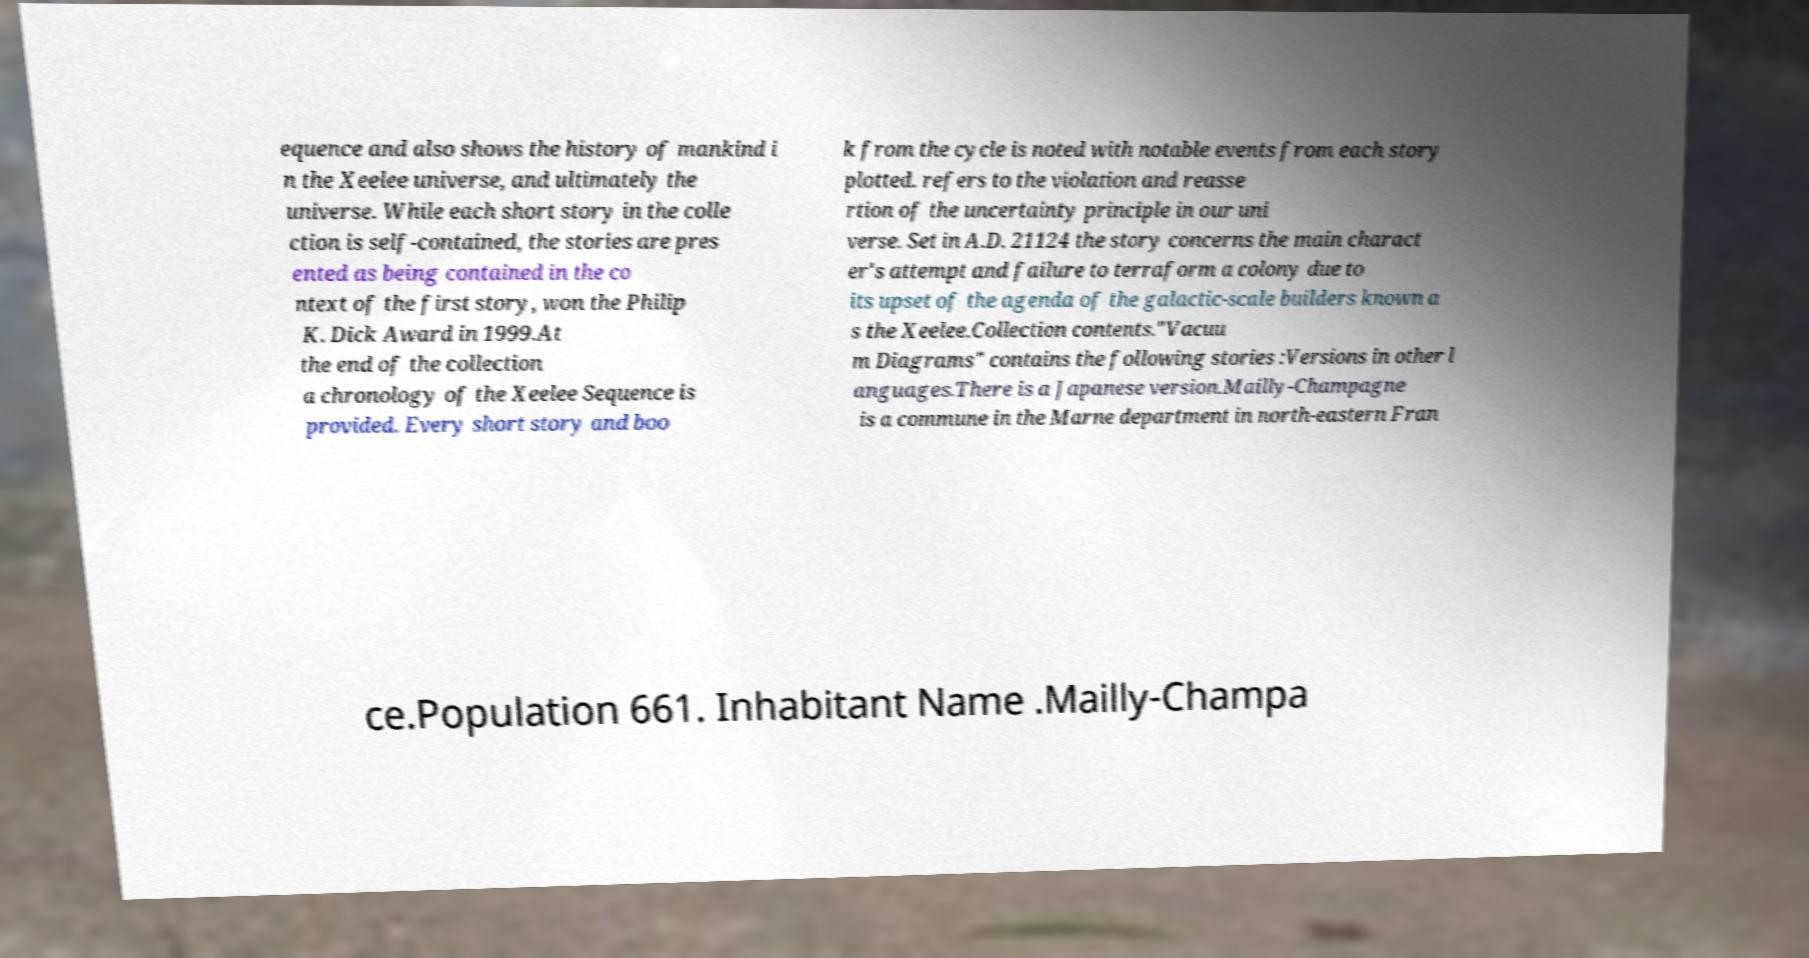There's text embedded in this image that I need extracted. Can you transcribe it verbatim? equence and also shows the history of mankind i n the Xeelee universe, and ultimately the universe. While each short story in the colle ction is self-contained, the stories are pres ented as being contained in the co ntext of the first story, won the Philip K. Dick Award in 1999.At the end of the collection a chronology of the Xeelee Sequence is provided. Every short story and boo k from the cycle is noted with notable events from each story plotted. refers to the violation and reasse rtion of the uncertainty principle in our uni verse. Set in A.D. 21124 the story concerns the main charact er's attempt and failure to terraform a colony due to its upset of the agenda of the galactic-scale builders known a s the Xeelee.Collection contents."Vacuu m Diagrams" contains the following stories :Versions in other l anguages.There is a Japanese version.Mailly-Champagne is a commune in the Marne department in north-eastern Fran ce.Population 661. Inhabitant Name .Mailly-Champa 